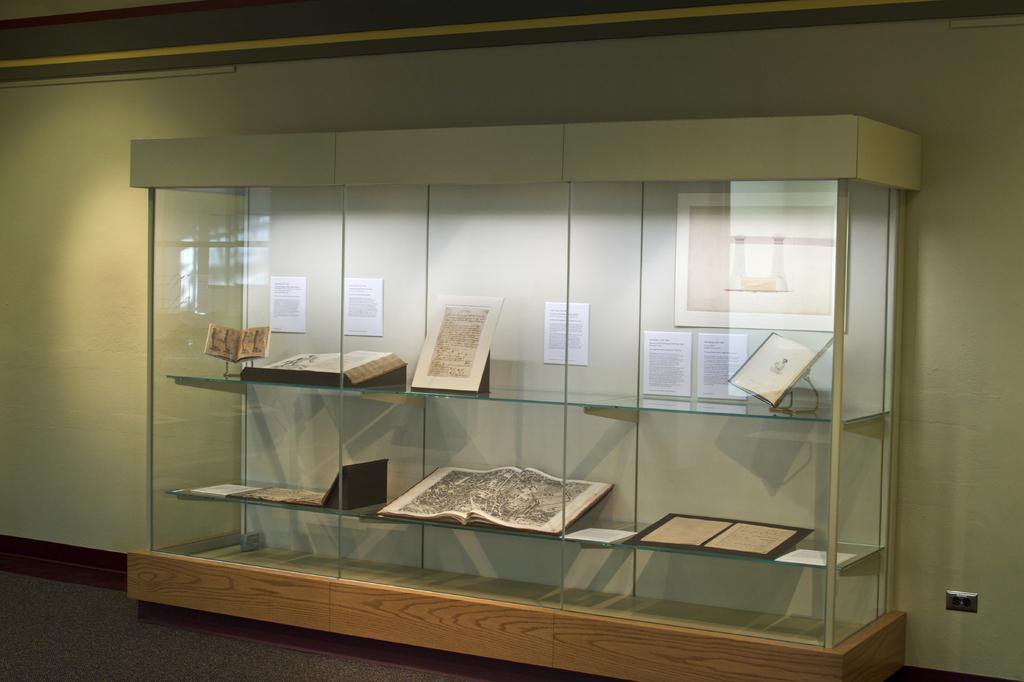In one or two sentences, can you explain what this image depicts? In this image there is a glass cabin having a glass cabin having few books on the shelves. Few posters and a frame is attached to the wall. 